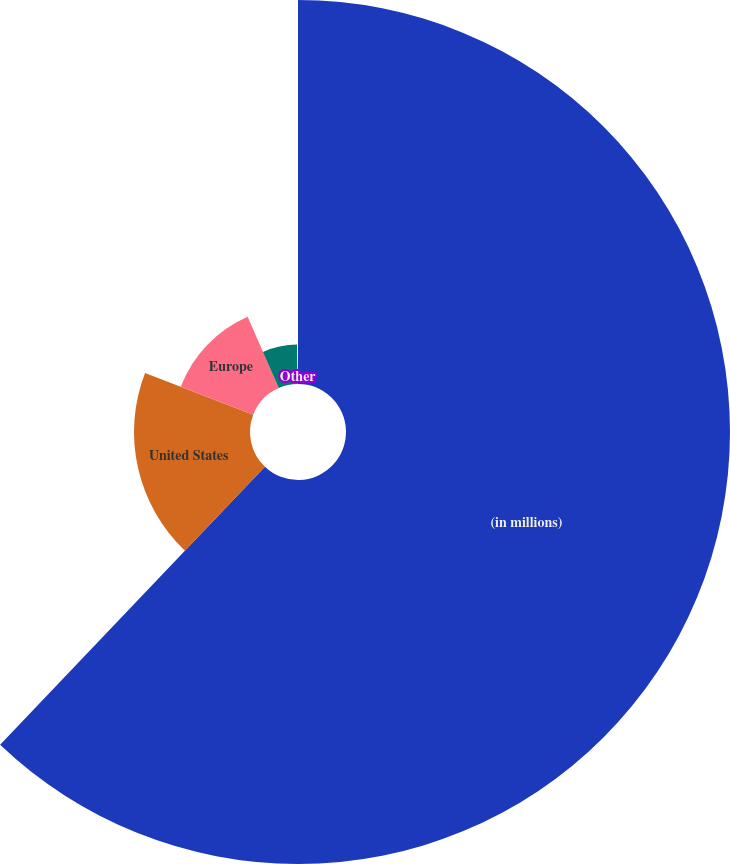Convert chart. <chart><loc_0><loc_0><loc_500><loc_500><pie_chart><fcel>(in millions)<fcel>United States<fcel>Europe<fcel>Asia Pacific<fcel>Other<nl><fcel>62.11%<fcel>18.76%<fcel>12.57%<fcel>6.38%<fcel>0.18%<nl></chart> 